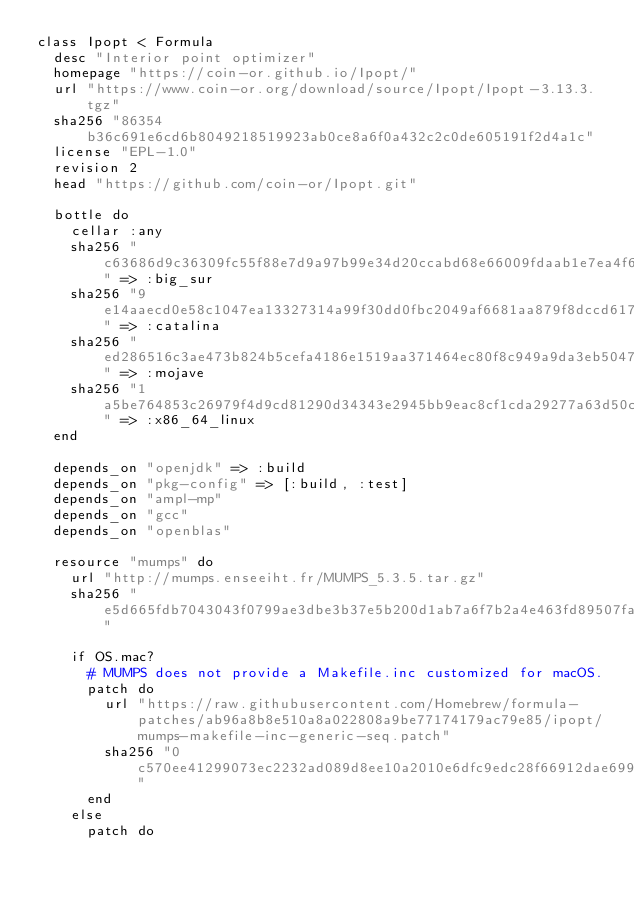Convert code to text. <code><loc_0><loc_0><loc_500><loc_500><_Ruby_>class Ipopt < Formula
  desc "Interior point optimizer"
  homepage "https://coin-or.github.io/Ipopt/"
  url "https://www.coin-or.org/download/source/Ipopt/Ipopt-3.13.3.tgz"
  sha256 "86354b36c691e6cd6b8049218519923ab0ce8a6f0a432c2c0de605191f2d4a1c"
  license "EPL-1.0"
  revision 2
  head "https://github.com/coin-or/Ipopt.git"

  bottle do
    cellar :any
    sha256 "c63686d9c36309fc55f88e7d9a97b99e34d20ccabd68e66009fdaab1e7ea4f6c" => :big_sur
    sha256 "9e14aaecd0e58c1047ea13327314a99f30dd0fbc2049af6681aa879f8dccd617" => :catalina
    sha256 "ed286516c3ae473b824b5cefa4186e1519aa371464ec80f8c949a9da3eb50475" => :mojave
    sha256 "1a5be764853c26979f4d9cd81290d34343e2945bb9eac8cf1cda29277a63d50c" => :x86_64_linux
  end

  depends_on "openjdk" => :build
  depends_on "pkg-config" => [:build, :test]
  depends_on "ampl-mp"
  depends_on "gcc"
  depends_on "openblas"

  resource "mumps" do
    url "http://mumps.enseeiht.fr/MUMPS_5.3.5.tar.gz"
    sha256 "e5d665fdb7043043f0799ae3dbe3b37e5b200d1ab7a6f7b2a4e463fd89507fa4"

    if OS.mac?
      # MUMPS does not provide a Makefile.inc customized for macOS.
      patch do
        url "https://raw.githubusercontent.com/Homebrew/formula-patches/ab96a8b8e510a8a022808a9be77174179ac79e85/ipopt/mumps-makefile-inc-generic-seq.patch"
        sha256 "0c570ee41299073ec2232ad089d8ee10a2010e6dfc9edc28f66912dae6999d75"
      end
    else
      patch do</code> 